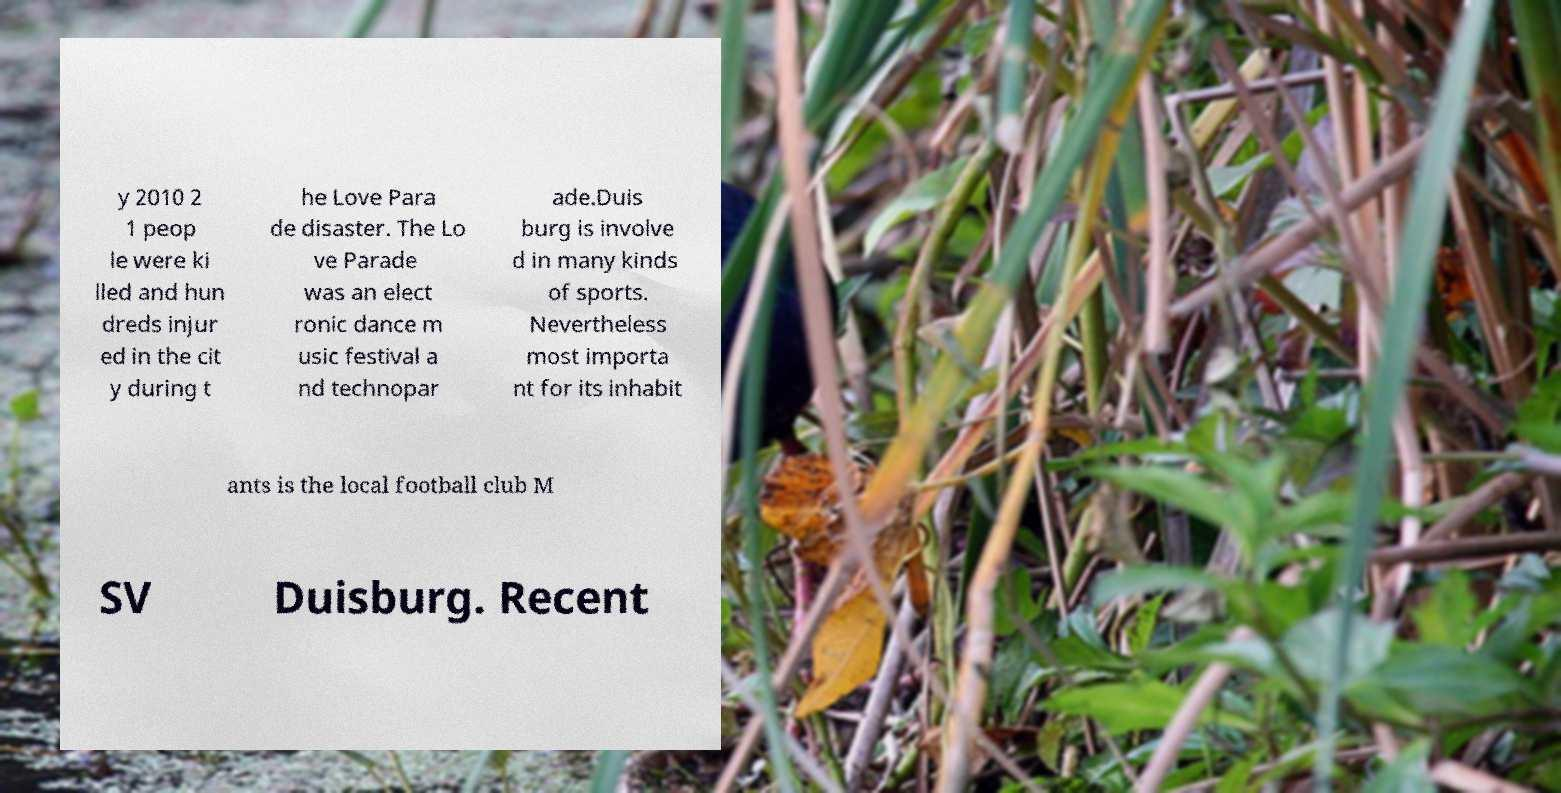Could you assist in decoding the text presented in this image and type it out clearly? y 2010 2 1 peop le were ki lled and hun dreds injur ed in the cit y during t he Love Para de disaster. The Lo ve Parade was an elect ronic dance m usic festival a nd technopar ade.Duis burg is involve d in many kinds of sports. Nevertheless most importa nt for its inhabit ants is the local football club M SV Duisburg. Recent 